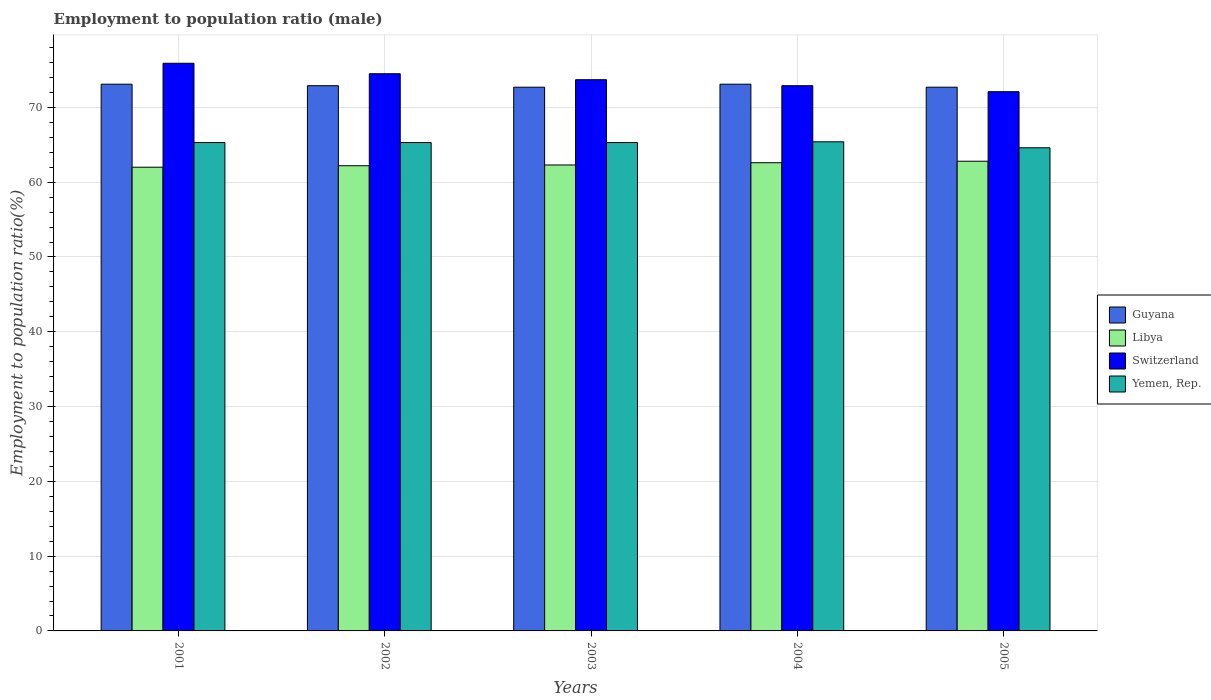How many different coloured bars are there?
Provide a succinct answer. 4. How many bars are there on the 1st tick from the right?
Your answer should be compact. 4. What is the label of the 4th group of bars from the left?
Your answer should be compact. 2004. In how many cases, is the number of bars for a given year not equal to the number of legend labels?
Your answer should be very brief. 0. What is the employment to population ratio in Switzerland in 2002?
Offer a very short reply. 74.5. Across all years, what is the maximum employment to population ratio in Switzerland?
Offer a terse response. 75.9. Across all years, what is the minimum employment to population ratio in Yemen, Rep.?
Keep it short and to the point. 64.6. In which year was the employment to population ratio in Libya maximum?
Your answer should be very brief. 2005. What is the total employment to population ratio in Guyana in the graph?
Keep it short and to the point. 364.5. What is the difference between the employment to population ratio in Libya in 2002 and that in 2003?
Your response must be concise. -0.1. What is the difference between the employment to population ratio in Yemen, Rep. in 2001 and the employment to population ratio in Libya in 2004?
Your answer should be very brief. 2.7. What is the average employment to population ratio in Switzerland per year?
Provide a succinct answer. 73.82. In the year 2003, what is the difference between the employment to population ratio in Switzerland and employment to population ratio in Yemen, Rep.?
Your answer should be very brief. 8.4. What is the ratio of the employment to population ratio in Switzerland in 2002 to that in 2004?
Offer a very short reply. 1.02. Is the employment to population ratio in Switzerland in 2001 less than that in 2004?
Your response must be concise. No. What is the difference between the highest and the second highest employment to population ratio in Guyana?
Provide a short and direct response. 0. What is the difference between the highest and the lowest employment to population ratio in Libya?
Provide a succinct answer. 0.8. What does the 2nd bar from the left in 2001 represents?
Provide a short and direct response. Libya. What does the 3rd bar from the right in 2003 represents?
Give a very brief answer. Libya. Is it the case that in every year, the sum of the employment to population ratio in Yemen, Rep. and employment to population ratio in Guyana is greater than the employment to population ratio in Switzerland?
Your response must be concise. Yes. How many bars are there?
Your answer should be very brief. 20. Are the values on the major ticks of Y-axis written in scientific E-notation?
Your response must be concise. No. What is the title of the graph?
Your answer should be very brief. Employment to population ratio (male). Does "Bosnia and Herzegovina" appear as one of the legend labels in the graph?
Your answer should be compact. No. What is the label or title of the X-axis?
Give a very brief answer. Years. What is the label or title of the Y-axis?
Your answer should be very brief. Employment to population ratio(%). What is the Employment to population ratio(%) of Guyana in 2001?
Keep it short and to the point. 73.1. What is the Employment to population ratio(%) of Switzerland in 2001?
Give a very brief answer. 75.9. What is the Employment to population ratio(%) of Yemen, Rep. in 2001?
Your answer should be very brief. 65.3. What is the Employment to population ratio(%) in Guyana in 2002?
Ensure brevity in your answer.  72.9. What is the Employment to population ratio(%) in Libya in 2002?
Your response must be concise. 62.2. What is the Employment to population ratio(%) in Switzerland in 2002?
Provide a succinct answer. 74.5. What is the Employment to population ratio(%) in Yemen, Rep. in 2002?
Offer a very short reply. 65.3. What is the Employment to population ratio(%) of Guyana in 2003?
Offer a very short reply. 72.7. What is the Employment to population ratio(%) in Libya in 2003?
Your answer should be compact. 62.3. What is the Employment to population ratio(%) of Switzerland in 2003?
Your answer should be compact. 73.7. What is the Employment to population ratio(%) in Yemen, Rep. in 2003?
Give a very brief answer. 65.3. What is the Employment to population ratio(%) in Guyana in 2004?
Give a very brief answer. 73.1. What is the Employment to population ratio(%) of Libya in 2004?
Your response must be concise. 62.6. What is the Employment to population ratio(%) of Switzerland in 2004?
Make the answer very short. 72.9. What is the Employment to population ratio(%) in Yemen, Rep. in 2004?
Provide a short and direct response. 65.4. What is the Employment to population ratio(%) of Guyana in 2005?
Make the answer very short. 72.7. What is the Employment to population ratio(%) of Libya in 2005?
Your answer should be very brief. 62.8. What is the Employment to population ratio(%) of Switzerland in 2005?
Your response must be concise. 72.1. What is the Employment to population ratio(%) in Yemen, Rep. in 2005?
Make the answer very short. 64.6. Across all years, what is the maximum Employment to population ratio(%) in Guyana?
Offer a terse response. 73.1. Across all years, what is the maximum Employment to population ratio(%) of Libya?
Provide a short and direct response. 62.8. Across all years, what is the maximum Employment to population ratio(%) of Switzerland?
Offer a very short reply. 75.9. Across all years, what is the maximum Employment to population ratio(%) of Yemen, Rep.?
Offer a terse response. 65.4. Across all years, what is the minimum Employment to population ratio(%) of Guyana?
Offer a very short reply. 72.7. Across all years, what is the minimum Employment to population ratio(%) in Libya?
Provide a succinct answer. 62. Across all years, what is the minimum Employment to population ratio(%) of Switzerland?
Your answer should be compact. 72.1. Across all years, what is the minimum Employment to population ratio(%) of Yemen, Rep.?
Your answer should be compact. 64.6. What is the total Employment to population ratio(%) of Guyana in the graph?
Your answer should be compact. 364.5. What is the total Employment to population ratio(%) of Libya in the graph?
Give a very brief answer. 311.9. What is the total Employment to population ratio(%) in Switzerland in the graph?
Offer a terse response. 369.1. What is the total Employment to population ratio(%) in Yemen, Rep. in the graph?
Your answer should be very brief. 325.9. What is the difference between the Employment to population ratio(%) in Guyana in 2001 and that in 2002?
Give a very brief answer. 0.2. What is the difference between the Employment to population ratio(%) in Guyana in 2001 and that in 2003?
Your response must be concise. 0.4. What is the difference between the Employment to population ratio(%) of Libya in 2001 and that in 2003?
Provide a succinct answer. -0.3. What is the difference between the Employment to population ratio(%) of Switzerland in 2001 and that in 2003?
Your answer should be very brief. 2.2. What is the difference between the Employment to population ratio(%) of Yemen, Rep. in 2001 and that in 2003?
Your answer should be compact. 0. What is the difference between the Employment to population ratio(%) of Guyana in 2001 and that in 2004?
Keep it short and to the point. 0. What is the difference between the Employment to population ratio(%) in Libya in 2001 and that in 2004?
Provide a short and direct response. -0.6. What is the difference between the Employment to population ratio(%) of Yemen, Rep. in 2001 and that in 2004?
Provide a short and direct response. -0.1. What is the difference between the Employment to population ratio(%) of Yemen, Rep. in 2001 and that in 2005?
Your answer should be very brief. 0.7. What is the difference between the Employment to population ratio(%) in Libya in 2002 and that in 2003?
Provide a succinct answer. -0.1. What is the difference between the Employment to population ratio(%) in Switzerland in 2002 and that in 2003?
Ensure brevity in your answer.  0.8. What is the difference between the Employment to population ratio(%) in Guyana in 2002 and that in 2004?
Offer a very short reply. -0.2. What is the difference between the Employment to population ratio(%) of Yemen, Rep. in 2002 and that in 2004?
Your answer should be very brief. -0.1. What is the difference between the Employment to population ratio(%) of Guyana in 2002 and that in 2005?
Your answer should be compact. 0.2. What is the difference between the Employment to population ratio(%) in Libya in 2002 and that in 2005?
Ensure brevity in your answer.  -0.6. What is the difference between the Employment to population ratio(%) in Switzerland in 2003 and that in 2004?
Your answer should be compact. 0.8. What is the difference between the Employment to population ratio(%) in Yemen, Rep. in 2003 and that in 2004?
Ensure brevity in your answer.  -0.1. What is the difference between the Employment to population ratio(%) of Guyana in 2003 and that in 2005?
Ensure brevity in your answer.  0. What is the difference between the Employment to population ratio(%) of Libya in 2003 and that in 2005?
Provide a short and direct response. -0.5. What is the difference between the Employment to population ratio(%) in Switzerland in 2003 and that in 2005?
Give a very brief answer. 1.6. What is the difference between the Employment to population ratio(%) of Guyana in 2004 and that in 2005?
Your response must be concise. 0.4. What is the difference between the Employment to population ratio(%) of Libya in 2004 and that in 2005?
Give a very brief answer. -0.2. What is the difference between the Employment to population ratio(%) of Switzerland in 2004 and that in 2005?
Make the answer very short. 0.8. What is the difference between the Employment to population ratio(%) of Yemen, Rep. in 2004 and that in 2005?
Offer a very short reply. 0.8. What is the difference between the Employment to population ratio(%) in Guyana in 2001 and the Employment to population ratio(%) in Yemen, Rep. in 2002?
Provide a short and direct response. 7.8. What is the difference between the Employment to population ratio(%) in Libya in 2001 and the Employment to population ratio(%) in Yemen, Rep. in 2002?
Offer a terse response. -3.3. What is the difference between the Employment to population ratio(%) in Guyana in 2001 and the Employment to population ratio(%) in Libya in 2003?
Ensure brevity in your answer.  10.8. What is the difference between the Employment to population ratio(%) in Guyana in 2001 and the Employment to population ratio(%) in Switzerland in 2003?
Make the answer very short. -0.6. What is the difference between the Employment to population ratio(%) of Guyana in 2001 and the Employment to population ratio(%) of Yemen, Rep. in 2003?
Provide a short and direct response. 7.8. What is the difference between the Employment to population ratio(%) of Libya in 2001 and the Employment to population ratio(%) of Switzerland in 2003?
Offer a terse response. -11.7. What is the difference between the Employment to population ratio(%) in Libya in 2001 and the Employment to population ratio(%) in Yemen, Rep. in 2003?
Your answer should be very brief. -3.3. What is the difference between the Employment to population ratio(%) in Switzerland in 2001 and the Employment to population ratio(%) in Yemen, Rep. in 2003?
Provide a short and direct response. 10.6. What is the difference between the Employment to population ratio(%) in Libya in 2001 and the Employment to population ratio(%) in Yemen, Rep. in 2004?
Offer a terse response. -3.4. What is the difference between the Employment to population ratio(%) of Guyana in 2001 and the Employment to population ratio(%) of Libya in 2005?
Provide a short and direct response. 10.3. What is the difference between the Employment to population ratio(%) of Guyana in 2001 and the Employment to population ratio(%) of Yemen, Rep. in 2005?
Give a very brief answer. 8.5. What is the difference between the Employment to population ratio(%) of Libya in 2001 and the Employment to population ratio(%) of Switzerland in 2005?
Give a very brief answer. -10.1. What is the difference between the Employment to population ratio(%) of Libya in 2001 and the Employment to population ratio(%) of Yemen, Rep. in 2005?
Offer a very short reply. -2.6. What is the difference between the Employment to population ratio(%) of Switzerland in 2001 and the Employment to population ratio(%) of Yemen, Rep. in 2005?
Your answer should be compact. 11.3. What is the difference between the Employment to population ratio(%) in Guyana in 2002 and the Employment to population ratio(%) in Switzerland in 2003?
Keep it short and to the point. -0.8. What is the difference between the Employment to population ratio(%) in Guyana in 2002 and the Employment to population ratio(%) in Libya in 2004?
Make the answer very short. 10.3. What is the difference between the Employment to population ratio(%) of Libya in 2002 and the Employment to population ratio(%) of Switzerland in 2004?
Offer a very short reply. -10.7. What is the difference between the Employment to population ratio(%) of Libya in 2002 and the Employment to population ratio(%) of Yemen, Rep. in 2004?
Provide a short and direct response. -3.2. What is the difference between the Employment to population ratio(%) of Guyana in 2002 and the Employment to population ratio(%) of Yemen, Rep. in 2005?
Provide a succinct answer. 8.3. What is the difference between the Employment to population ratio(%) in Libya in 2002 and the Employment to population ratio(%) in Yemen, Rep. in 2005?
Ensure brevity in your answer.  -2.4. What is the difference between the Employment to population ratio(%) of Guyana in 2003 and the Employment to population ratio(%) of Libya in 2004?
Ensure brevity in your answer.  10.1. What is the difference between the Employment to population ratio(%) of Libya in 2003 and the Employment to population ratio(%) of Switzerland in 2004?
Offer a terse response. -10.6. What is the difference between the Employment to population ratio(%) of Libya in 2003 and the Employment to population ratio(%) of Yemen, Rep. in 2004?
Keep it short and to the point. -3.1. What is the difference between the Employment to population ratio(%) of Libya in 2003 and the Employment to population ratio(%) of Yemen, Rep. in 2005?
Your response must be concise. -2.3. What is the difference between the Employment to population ratio(%) in Libya in 2004 and the Employment to population ratio(%) in Switzerland in 2005?
Provide a succinct answer. -9.5. What is the difference between the Employment to population ratio(%) of Libya in 2004 and the Employment to population ratio(%) of Yemen, Rep. in 2005?
Your answer should be very brief. -2. What is the average Employment to population ratio(%) in Guyana per year?
Make the answer very short. 72.9. What is the average Employment to population ratio(%) of Libya per year?
Keep it short and to the point. 62.38. What is the average Employment to population ratio(%) in Switzerland per year?
Keep it short and to the point. 73.82. What is the average Employment to population ratio(%) of Yemen, Rep. per year?
Make the answer very short. 65.18. In the year 2001, what is the difference between the Employment to population ratio(%) of Guyana and Employment to population ratio(%) of Switzerland?
Provide a succinct answer. -2.8. In the year 2001, what is the difference between the Employment to population ratio(%) in Guyana and Employment to population ratio(%) in Yemen, Rep.?
Provide a succinct answer. 7.8. In the year 2001, what is the difference between the Employment to population ratio(%) of Libya and Employment to population ratio(%) of Switzerland?
Keep it short and to the point. -13.9. In the year 2001, what is the difference between the Employment to population ratio(%) of Switzerland and Employment to population ratio(%) of Yemen, Rep.?
Make the answer very short. 10.6. In the year 2002, what is the difference between the Employment to population ratio(%) in Guyana and Employment to population ratio(%) in Libya?
Offer a terse response. 10.7. In the year 2002, what is the difference between the Employment to population ratio(%) of Libya and Employment to population ratio(%) of Yemen, Rep.?
Offer a terse response. -3.1. In the year 2002, what is the difference between the Employment to population ratio(%) of Switzerland and Employment to population ratio(%) of Yemen, Rep.?
Your answer should be very brief. 9.2. In the year 2003, what is the difference between the Employment to population ratio(%) in Guyana and Employment to population ratio(%) in Libya?
Ensure brevity in your answer.  10.4. In the year 2003, what is the difference between the Employment to population ratio(%) in Guyana and Employment to population ratio(%) in Switzerland?
Provide a succinct answer. -1. In the year 2003, what is the difference between the Employment to population ratio(%) of Guyana and Employment to population ratio(%) of Yemen, Rep.?
Provide a short and direct response. 7.4. In the year 2003, what is the difference between the Employment to population ratio(%) of Libya and Employment to population ratio(%) of Switzerland?
Offer a very short reply. -11.4. In the year 2003, what is the difference between the Employment to population ratio(%) in Switzerland and Employment to population ratio(%) in Yemen, Rep.?
Provide a succinct answer. 8.4. In the year 2004, what is the difference between the Employment to population ratio(%) of Guyana and Employment to population ratio(%) of Libya?
Your answer should be very brief. 10.5. In the year 2004, what is the difference between the Employment to population ratio(%) of Guyana and Employment to population ratio(%) of Yemen, Rep.?
Make the answer very short. 7.7. In the year 2004, what is the difference between the Employment to population ratio(%) in Libya and Employment to population ratio(%) in Yemen, Rep.?
Your answer should be compact. -2.8. In the year 2004, what is the difference between the Employment to population ratio(%) of Switzerland and Employment to population ratio(%) of Yemen, Rep.?
Keep it short and to the point. 7.5. In the year 2005, what is the difference between the Employment to population ratio(%) in Switzerland and Employment to population ratio(%) in Yemen, Rep.?
Provide a succinct answer. 7.5. What is the ratio of the Employment to population ratio(%) of Libya in 2001 to that in 2002?
Your response must be concise. 1. What is the ratio of the Employment to population ratio(%) in Switzerland in 2001 to that in 2002?
Ensure brevity in your answer.  1.02. What is the ratio of the Employment to population ratio(%) in Yemen, Rep. in 2001 to that in 2002?
Provide a succinct answer. 1. What is the ratio of the Employment to population ratio(%) of Libya in 2001 to that in 2003?
Your answer should be very brief. 1. What is the ratio of the Employment to population ratio(%) in Switzerland in 2001 to that in 2003?
Provide a short and direct response. 1.03. What is the ratio of the Employment to population ratio(%) in Yemen, Rep. in 2001 to that in 2003?
Offer a terse response. 1. What is the ratio of the Employment to population ratio(%) in Libya in 2001 to that in 2004?
Offer a terse response. 0.99. What is the ratio of the Employment to population ratio(%) in Switzerland in 2001 to that in 2004?
Ensure brevity in your answer.  1.04. What is the ratio of the Employment to population ratio(%) of Yemen, Rep. in 2001 to that in 2004?
Your response must be concise. 1. What is the ratio of the Employment to population ratio(%) of Libya in 2001 to that in 2005?
Make the answer very short. 0.99. What is the ratio of the Employment to population ratio(%) of Switzerland in 2001 to that in 2005?
Offer a terse response. 1.05. What is the ratio of the Employment to population ratio(%) in Yemen, Rep. in 2001 to that in 2005?
Ensure brevity in your answer.  1.01. What is the ratio of the Employment to population ratio(%) in Switzerland in 2002 to that in 2003?
Provide a succinct answer. 1.01. What is the ratio of the Employment to population ratio(%) in Yemen, Rep. in 2002 to that in 2003?
Make the answer very short. 1. What is the ratio of the Employment to population ratio(%) of Guyana in 2002 to that in 2004?
Keep it short and to the point. 1. What is the ratio of the Employment to population ratio(%) in Switzerland in 2002 to that in 2004?
Give a very brief answer. 1.02. What is the ratio of the Employment to population ratio(%) in Libya in 2002 to that in 2005?
Keep it short and to the point. 0.99. What is the ratio of the Employment to population ratio(%) in Yemen, Rep. in 2002 to that in 2005?
Provide a succinct answer. 1.01. What is the ratio of the Employment to population ratio(%) in Guyana in 2003 to that in 2004?
Provide a short and direct response. 0.99. What is the ratio of the Employment to population ratio(%) of Yemen, Rep. in 2003 to that in 2004?
Your answer should be compact. 1. What is the ratio of the Employment to population ratio(%) in Libya in 2003 to that in 2005?
Provide a short and direct response. 0.99. What is the ratio of the Employment to population ratio(%) in Switzerland in 2003 to that in 2005?
Provide a short and direct response. 1.02. What is the ratio of the Employment to population ratio(%) in Yemen, Rep. in 2003 to that in 2005?
Make the answer very short. 1.01. What is the ratio of the Employment to population ratio(%) in Switzerland in 2004 to that in 2005?
Make the answer very short. 1.01. What is the ratio of the Employment to population ratio(%) of Yemen, Rep. in 2004 to that in 2005?
Offer a terse response. 1.01. What is the difference between the highest and the second highest Employment to population ratio(%) in Switzerland?
Your answer should be compact. 1.4. 